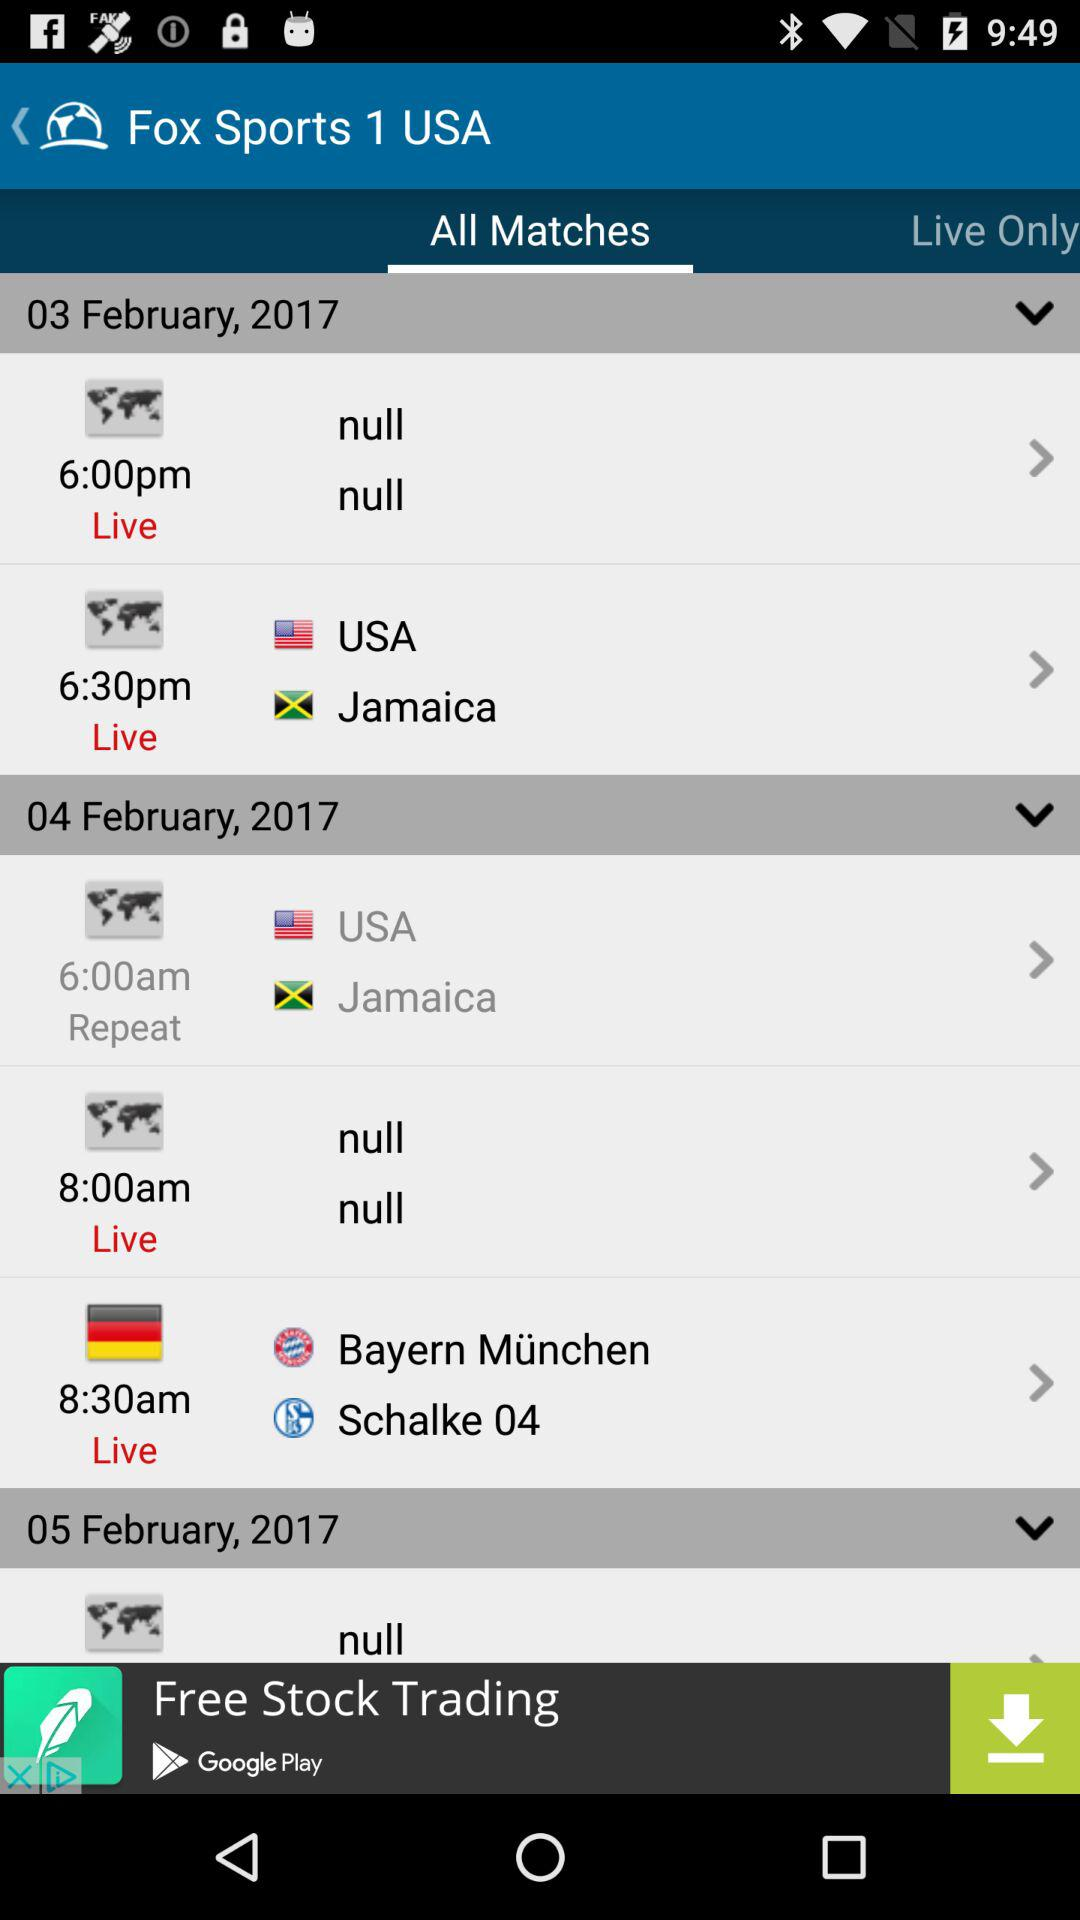At what time is the live match between "Bayern München" and "Schalke 04" scheduled? The live match between "Bayern München" and "Schalke 04" is scheduled at 8:30 a.m. 